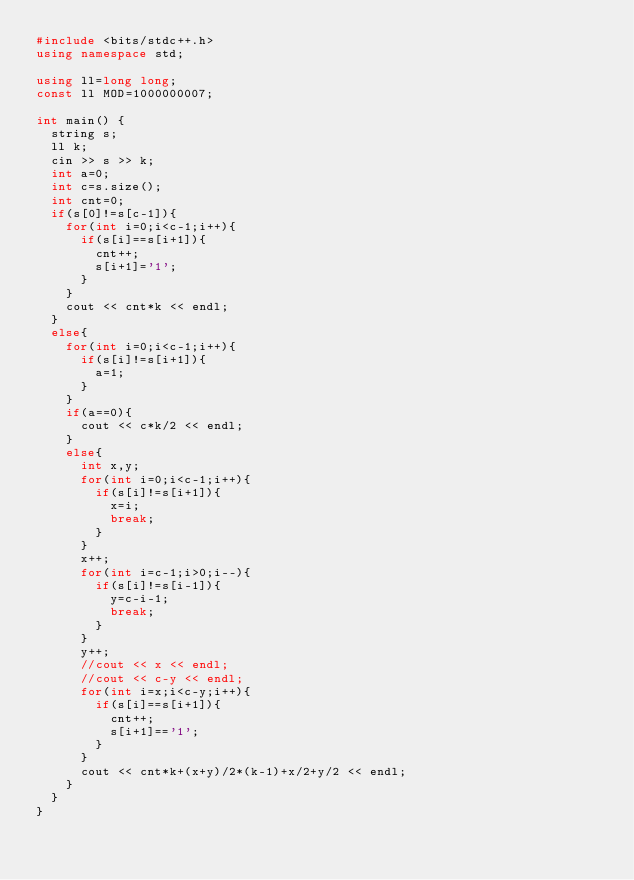Convert code to text. <code><loc_0><loc_0><loc_500><loc_500><_C++_>#include <bits/stdc++.h>
using namespace std;

using ll=long long;
const ll MOD=1000000007;

int main() {
  string s;
  ll k;
  cin >> s >> k;
  int a=0;
  int c=s.size();
  int cnt=0;
  if(s[0]!=s[c-1]){
    for(int i=0;i<c-1;i++){
      if(s[i]==s[i+1]){
        cnt++;
        s[i+1]='1';
      }
    }
    cout << cnt*k << endl;
  }
  else{
    for(int i=0;i<c-1;i++){
      if(s[i]!=s[i+1]){
        a=1;
      }
    }
    if(a==0){
      cout << c*k/2 << endl;
    }
    else{
      int x,y;
      for(int i=0;i<c-1;i++){
        if(s[i]!=s[i+1]){
          x=i;
          break;
        }
      }
      x++;
      for(int i=c-1;i>0;i--){
        if(s[i]!=s[i-1]){
          y=c-i-1;
          break;
        }
      }
      y++;
      //cout << x << endl;
      //cout << c-y << endl;
      for(int i=x;i<c-y;i++){
        if(s[i]==s[i+1]){
          cnt++;
          s[i+1]=='1';
        }
      }
      cout << cnt*k+(x+y)/2*(k-1)+x/2+y/2 << endl;
    }
  }
}</code> 